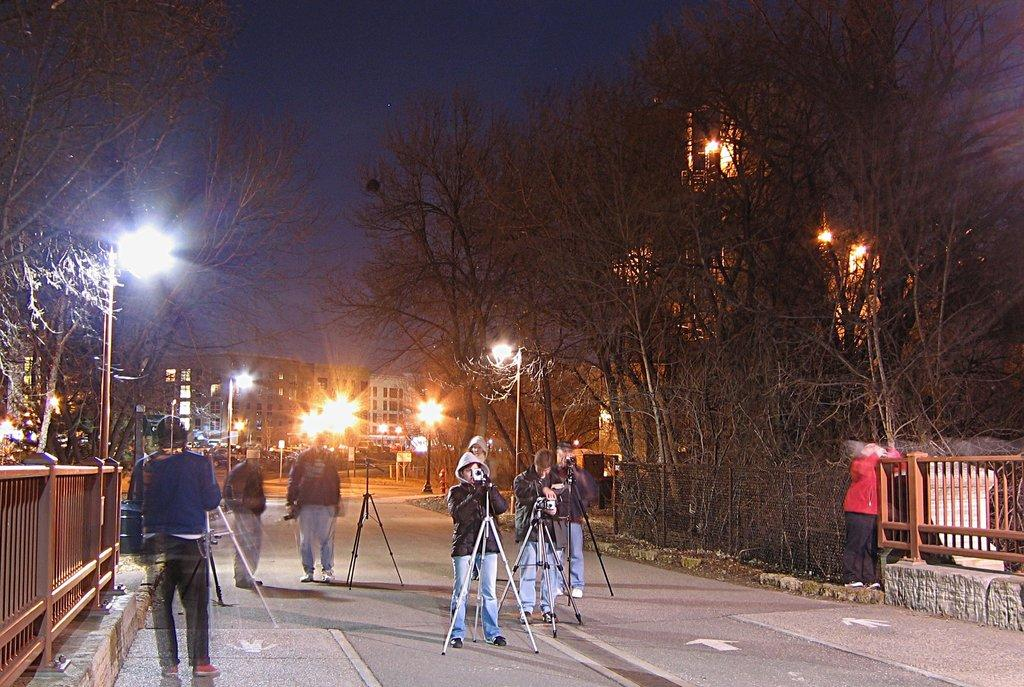How many people are in the image? There are people in the image, but the exact number is not specified. What are some people doing in the image? Some people are holding cameras in the image. What structures can be seen in the image? There are stands and railings visible in the image. What can be seen in the background of the image? In the background of the image, there are trees, poles, lights, buildings, and the sky. What type of cave can be seen in the image? There is no cave present in the image. What is the opinion of the people in the image about the voyage they are taking? The image does not provide any information about the people's opinions or a voyage they might be taking. 